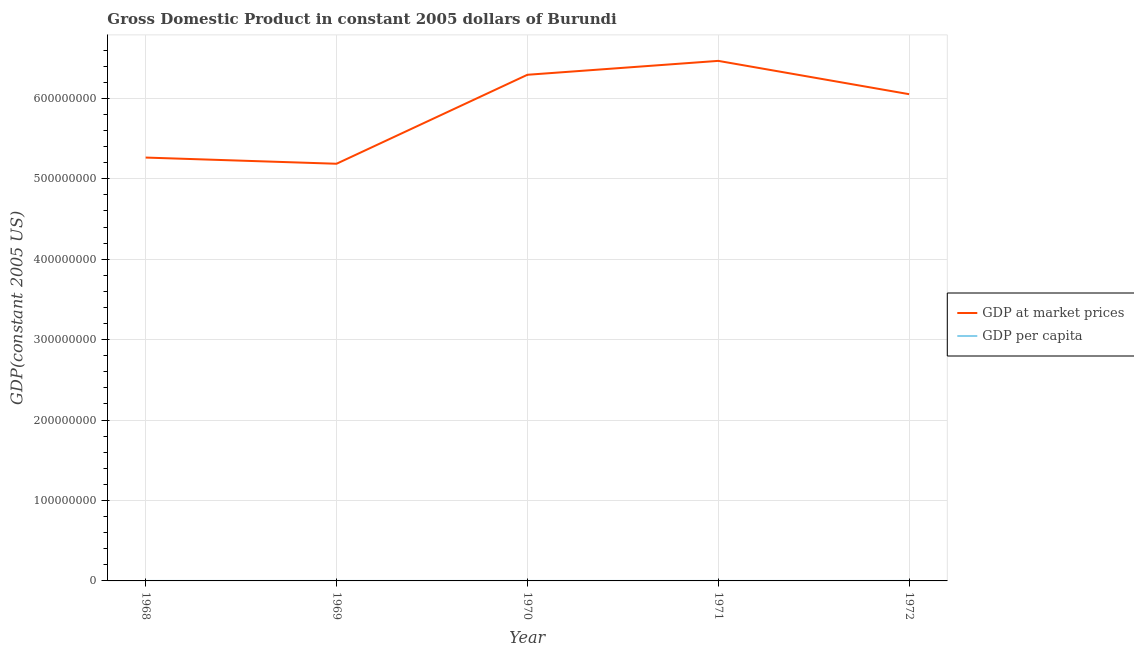How many different coloured lines are there?
Keep it short and to the point. 2. Does the line corresponding to gdp per capita intersect with the line corresponding to gdp at market prices?
Keep it short and to the point. No. What is the gdp per capita in 1969?
Provide a short and direct response. 152.88. Across all years, what is the maximum gdp per capita?
Make the answer very short. 184.35. Across all years, what is the minimum gdp per capita?
Provide a succinct answer. 152.88. In which year was the gdp at market prices maximum?
Your response must be concise. 1971. In which year was the gdp at market prices minimum?
Provide a short and direct response. 1969. What is the total gdp per capita in the graph?
Give a very brief answer. 848.58. What is the difference between the gdp per capita in 1969 and that in 1972?
Offer a very short reply. -17.73. What is the difference between the gdp per capita in 1972 and the gdp at market prices in 1969?
Your response must be concise. -5.19e+08. What is the average gdp at market prices per year?
Provide a succinct answer. 5.85e+08. In the year 1971, what is the difference between the gdp at market prices and gdp per capita?
Your answer should be very brief. 6.47e+08. In how many years, is the gdp at market prices greater than 300000000 US$?
Offer a terse response. 5. What is the ratio of the gdp per capita in 1968 to that in 1972?
Ensure brevity in your answer.  0.93. Is the gdp per capita in 1968 less than that in 1971?
Make the answer very short. Yes. Is the difference between the gdp at market prices in 1970 and 1972 greater than the difference between the gdp per capita in 1970 and 1972?
Provide a succinct answer. Yes. What is the difference between the highest and the second highest gdp per capita?
Offer a terse response. 2.31. What is the difference between the highest and the lowest gdp per capita?
Offer a terse response. 31.47. In how many years, is the gdp at market prices greater than the average gdp at market prices taken over all years?
Provide a succinct answer. 3. Does the gdp per capita monotonically increase over the years?
Provide a succinct answer. No. Is the gdp per capita strictly greater than the gdp at market prices over the years?
Ensure brevity in your answer.  No. How many years are there in the graph?
Give a very brief answer. 5. Does the graph contain any zero values?
Your answer should be very brief. No. Does the graph contain grids?
Your answer should be compact. Yes. How many legend labels are there?
Offer a terse response. 2. What is the title of the graph?
Keep it short and to the point. Gross Domestic Product in constant 2005 dollars of Burundi. What is the label or title of the X-axis?
Your answer should be compact. Year. What is the label or title of the Y-axis?
Your answer should be very brief. GDP(constant 2005 US). What is the GDP(constant 2005 US) in GDP at market prices in 1968?
Offer a terse response. 5.26e+08. What is the GDP(constant 2005 US) in GDP per capita in 1968?
Give a very brief answer. 158.68. What is the GDP(constant 2005 US) of GDP at market prices in 1969?
Ensure brevity in your answer.  5.19e+08. What is the GDP(constant 2005 US) in GDP per capita in 1969?
Provide a succinct answer. 152.88. What is the GDP(constant 2005 US) in GDP at market prices in 1970?
Offer a terse response. 6.29e+08. What is the GDP(constant 2005 US) of GDP per capita in 1970?
Provide a short and direct response. 182.04. What is the GDP(constant 2005 US) in GDP at market prices in 1971?
Offer a terse response. 6.47e+08. What is the GDP(constant 2005 US) of GDP per capita in 1971?
Your response must be concise. 184.35. What is the GDP(constant 2005 US) in GDP at market prices in 1972?
Keep it short and to the point. 6.05e+08. What is the GDP(constant 2005 US) of GDP per capita in 1972?
Provide a succinct answer. 170.61. Across all years, what is the maximum GDP(constant 2005 US) of GDP at market prices?
Your answer should be very brief. 6.47e+08. Across all years, what is the maximum GDP(constant 2005 US) of GDP per capita?
Make the answer very short. 184.35. Across all years, what is the minimum GDP(constant 2005 US) of GDP at market prices?
Ensure brevity in your answer.  5.19e+08. Across all years, what is the minimum GDP(constant 2005 US) of GDP per capita?
Offer a terse response. 152.88. What is the total GDP(constant 2005 US) in GDP at market prices in the graph?
Your response must be concise. 2.93e+09. What is the total GDP(constant 2005 US) in GDP per capita in the graph?
Keep it short and to the point. 848.58. What is the difference between the GDP(constant 2005 US) in GDP at market prices in 1968 and that in 1969?
Provide a succinct answer. 7.68e+06. What is the difference between the GDP(constant 2005 US) in GDP per capita in 1968 and that in 1969?
Keep it short and to the point. 5.8. What is the difference between the GDP(constant 2005 US) in GDP at market prices in 1968 and that in 1970?
Your response must be concise. -1.03e+08. What is the difference between the GDP(constant 2005 US) in GDP per capita in 1968 and that in 1970?
Your answer should be compact. -23.36. What is the difference between the GDP(constant 2005 US) of GDP at market prices in 1968 and that in 1971?
Give a very brief answer. -1.20e+08. What is the difference between the GDP(constant 2005 US) in GDP per capita in 1968 and that in 1971?
Your answer should be very brief. -25.67. What is the difference between the GDP(constant 2005 US) in GDP at market prices in 1968 and that in 1972?
Your answer should be very brief. -7.88e+07. What is the difference between the GDP(constant 2005 US) in GDP per capita in 1968 and that in 1972?
Provide a short and direct response. -11.93. What is the difference between the GDP(constant 2005 US) of GDP at market prices in 1969 and that in 1970?
Your answer should be very brief. -1.11e+08. What is the difference between the GDP(constant 2005 US) in GDP per capita in 1969 and that in 1970?
Give a very brief answer. -29.16. What is the difference between the GDP(constant 2005 US) of GDP at market prices in 1969 and that in 1971?
Your answer should be very brief. -1.28e+08. What is the difference between the GDP(constant 2005 US) of GDP per capita in 1969 and that in 1971?
Give a very brief answer. -31.47. What is the difference between the GDP(constant 2005 US) of GDP at market prices in 1969 and that in 1972?
Your response must be concise. -8.65e+07. What is the difference between the GDP(constant 2005 US) in GDP per capita in 1969 and that in 1972?
Offer a very short reply. -17.73. What is the difference between the GDP(constant 2005 US) in GDP at market prices in 1970 and that in 1971?
Your answer should be very brief. -1.73e+07. What is the difference between the GDP(constant 2005 US) of GDP per capita in 1970 and that in 1971?
Ensure brevity in your answer.  -2.31. What is the difference between the GDP(constant 2005 US) in GDP at market prices in 1970 and that in 1972?
Your answer should be compact. 2.41e+07. What is the difference between the GDP(constant 2005 US) of GDP per capita in 1970 and that in 1972?
Give a very brief answer. 11.43. What is the difference between the GDP(constant 2005 US) of GDP at market prices in 1971 and that in 1972?
Make the answer very short. 4.14e+07. What is the difference between the GDP(constant 2005 US) in GDP per capita in 1971 and that in 1972?
Ensure brevity in your answer.  13.74. What is the difference between the GDP(constant 2005 US) of GDP at market prices in 1968 and the GDP(constant 2005 US) of GDP per capita in 1969?
Provide a succinct answer. 5.26e+08. What is the difference between the GDP(constant 2005 US) of GDP at market prices in 1968 and the GDP(constant 2005 US) of GDP per capita in 1970?
Your answer should be compact. 5.26e+08. What is the difference between the GDP(constant 2005 US) in GDP at market prices in 1968 and the GDP(constant 2005 US) in GDP per capita in 1971?
Offer a very short reply. 5.26e+08. What is the difference between the GDP(constant 2005 US) of GDP at market prices in 1968 and the GDP(constant 2005 US) of GDP per capita in 1972?
Your answer should be compact. 5.26e+08. What is the difference between the GDP(constant 2005 US) in GDP at market prices in 1969 and the GDP(constant 2005 US) in GDP per capita in 1970?
Provide a short and direct response. 5.19e+08. What is the difference between the GDP(constant 2005 US) of GDP at market prices in 1969 and the GDP(constant 2005 US) of GDP per capita in 1971?
Provide a succinct answer. 5.19e+08. What is the difference between the GDP(constant 2005 US) of GDP at market prices in 1969 and the GDP(constant 2005 US) of GDP per capita in 1972?
Provide a short and direct response. 5.19e+08. What is the difference between the GDP(constant 2005 US) of GDP at market prices in 1970 and the GDP(constant 2005 US) of GDP per capita in 1971?
Your response must be concise. 6.29e+08. What is the difference between the GDP(constant 2005 US) of GDP at market prices in 1970 and the GDP(constant 2005 US) of GDP per capita in 1972?
Your response must be concise. 6.29e+08. What is the difference between the GDP(constant 2005 US) of GDP at market prices in 1971 and the GDP(constant 2005 US) of GDP per capita in 1972?
Keep it short and to the point. 6.47e+08. What is the average GDP(constant 2005 US) of GDP at market prices per year?
Give a very brief answer. 5.85e+08. What is the average GDP(constant 2005 US) in GDP per capita per year?
Make the answer very short. 169.72. In the year 1968, what is the difference between the GDP(constant 2005 US) in GDP at market prices and GDP(constant 2005 US) in GDP per capita?
Your response must be concise. 5.26e+08. In the year 1969, what is the difference between the GDP(constant 2005 US) of GDP at market prices and GDP(constant 2005 US) of GDP per capita?
Provide a succinct answer. 5.19e+08. In the year 1970, what is the difference between the GDP(constant 2005 US) in GDP at market prices and GDP(constant 2005 US) in GDP per capita?
Offer a very short reply. 6.29e+08. In the year 1971, what is the difference between the GDP(constant 2005 US) of GDP at market prices and GDP(constant 2005 US) of GDP per capita?
Give a very brief answer. 6.47e+08. In the year 1972, what is the difference between the GDP(constant 2005 US) in GDP at market prices and GDP(constant 2005 US) in GDP per capita?
Ensure brevity in your answer.  6.05e+08. What is the ratio of the GDP(constant 2005 US) of GDP at market prices in 1968 to that in 1969?
Your response must be concise. 1.01. What is the ratio of the GDP(constant 2005 US) in GDP per capita in 1968 to that in 1969?
Make the answer very short. 1.04. What is the ratio of the GDP(constant 2005 US) of GDP at market prices in 1968 to that in 1970?
Make the answer very short. 0.84. What is the ratio of the GDP(constant 2005 US) in GDP per capita in 1968 to that in 1970?
Offer a very short reply. 0.87. What is the ratio of the GDP(constant 2005 US) in GDP at market prices in 1968 to that in 1971?
Ensure brevity in your answer.  0.81. What is the ratio of the GDP(constant 2005 US) of GDP per capita in 1968 to that in 1971?
Your answer should be compact. 0.86. What is the ratio of the GDP(constant 2005 US) of GDP at market prices in 1968 to that in 1972?
Ensure brevity in your answer.  0.87. What is the ratio of the GDP(constant 2005 US) in GDP per capita in 1968 to that in 1972?
Give a very brief answer. 0.93. What is the ratio of the GDP(constant 2005 US) in GDP at market prices in 1969 to that in 1970?
Give a very brief answer. 0.82. What is the ratio of the GDP(constant 2005 US) in GDP per capita in 1969 to that in 1970?
Your answer should be compact. 0.84. What is the ratio of the GDP(constant 2005 US) in GDP at market prices in 1969 to that in 1971?
Ensure brevity in your answer.  0.8. What is the ratio of the GDP(constant 2005 US) in GDP per capita in 1969 to that in 1971?
Your answer should be compact. 0.83. What is the ratio of the GDP(constant 2005 US) of GDP at market prices in 1969 to that in 1972?
Your answer should be very brief. 0.86. What is the ratio of the GDP(constant 2005 US) in GDP per capita in 1969 to that in 1972?
Provide a short and direct response. 0.9. What is the ratio of the GDP(constant 2005 US) of GDP at market prices in 1970 to that in 1971?
Provide a succinct answer. 0.97. What is the ratio of the GDP(constant 2005 US) in GDP per capita in 1970 to that in 1971?
Make the answer very short. 0.99. What is the ratio of the GDP(constant 2005 US) in GDP at market prices in 1970 to that in 1972?
Ensure brevity in your answer.  1.04. What is the ratio of the GDP(constant 2005 US) in GDP per capita in 1970 to that in 1972?
Your answer should be compact. 1.07. What is the ratio of the GDP(constant 2005 US) in GDP at market prices in 1971 to that in 1972?
Your answer should be compact. 1.07. What is the ratio of the GDP(constant 2005 US) in GDP per capita in 1971 to that in 1972?
Offer a very short reply. 1.08. What is the difference between the highest and the second highest GDP(constant 2005 US) of GDP at market prices?
Make the answer very short. 1.73e+07. What is the difference between the highest and the second highest GDP(constant 2005 US) of GDP per capita?
Your response must be concise. 2.31. What is the difference between the highest and the lowest GDP(constant 2005 US) of GDP at market prices?
Your answer should be very brief. 1.28e+08. What is the difference between the highest and the lowest GDP(constant 2005 US) of GDP per capita?
Ensure brevity in your answer.  31.47. 